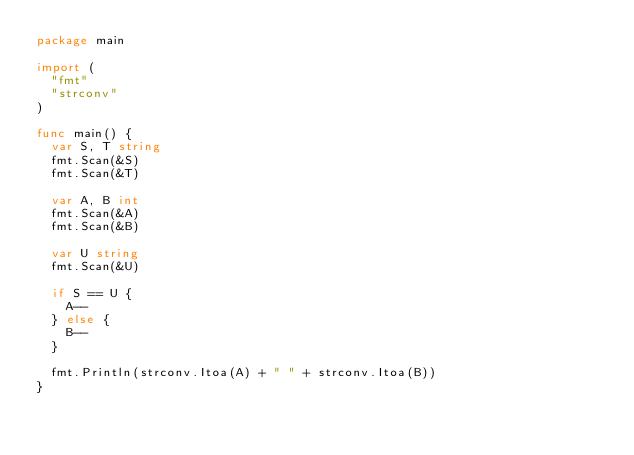Convert code to text. <code><loc_0><loc_0><loc_500><loc_500><_Go_>package main

import (
	"fmt"
	"strconv"
)

func main() {
	var S, T string
	fmt.Scan(&S)
	fmt.Scan(&T)

	var A, B int
	fmt.Scan(&A)
	fmt.Scan(&B)

	var U string
	fmt.Scan(&U)

	if S == U {
		A--
	} else {
		B--
	}

	fmt.Println(strconv.Itoa(A) + " " + strconv.Itoa(B))
}
</code> 